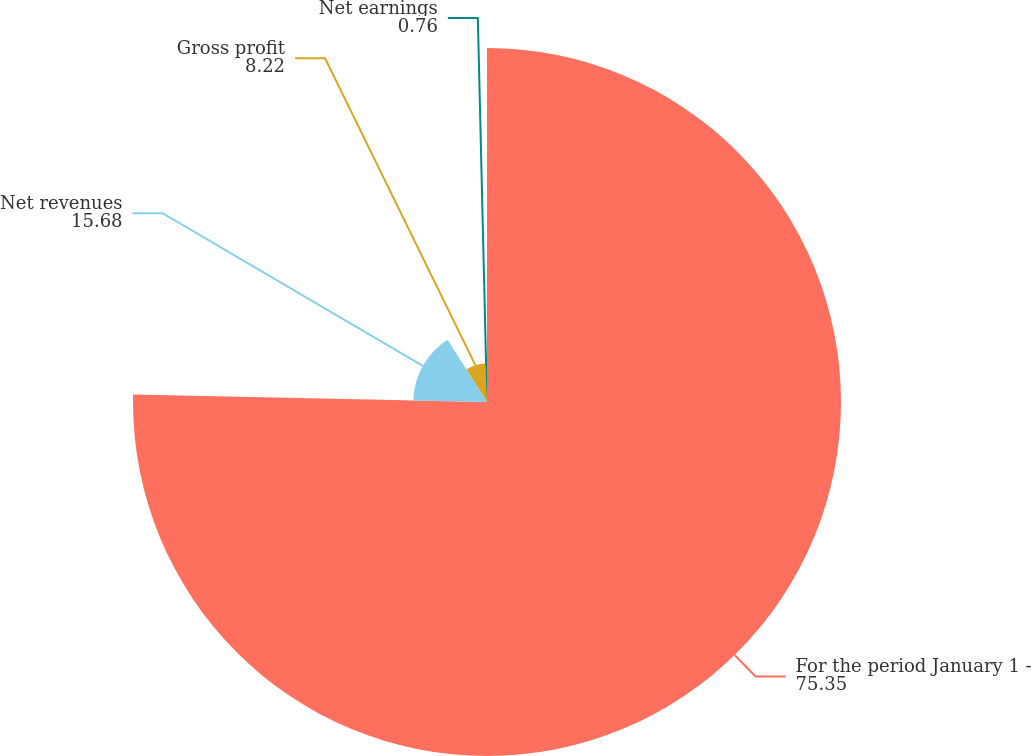Convert chart to OTSL. <chart><loc_0><loc_0><loc_500><loc_500><pie_chart><fcel>For the period January 1 -<fcel>Net revenues<fcel>Gross profit<fcel>Net earnings<nl><fcel>75.35%<fcel>15.68%<fcel>8.22%<fcel>0.76%<nl></chart> 